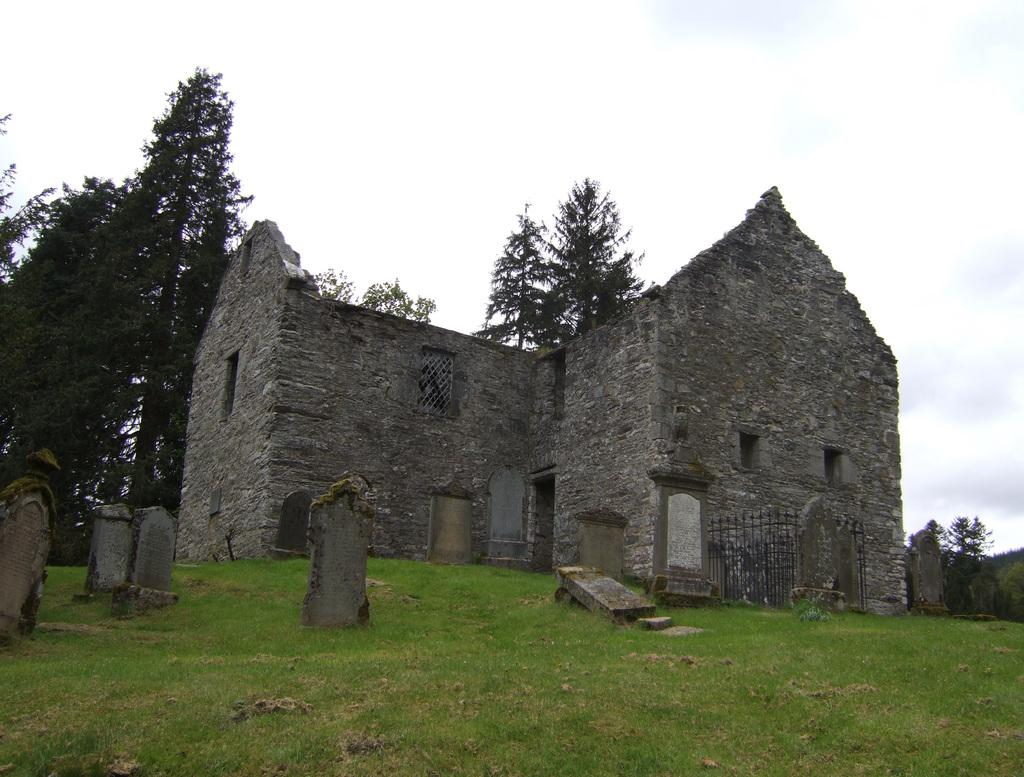What type of structure is present in the image? There is a building in the image. What type of mineral is visible in the image? There is agate in the image. What type of natural elements are present in the image? There are stones and grass visible in the image. What type of plant is present in the image? There is a tree in the image. What part of the natural environment is visible in the image? The sky is visible in the image. Where is the locket located in the image? There is no locket present in the image. What type of container is visible in the image? There is no tin container present in the image. What type of bird's home is present in the image? There is no nest present in the image. 